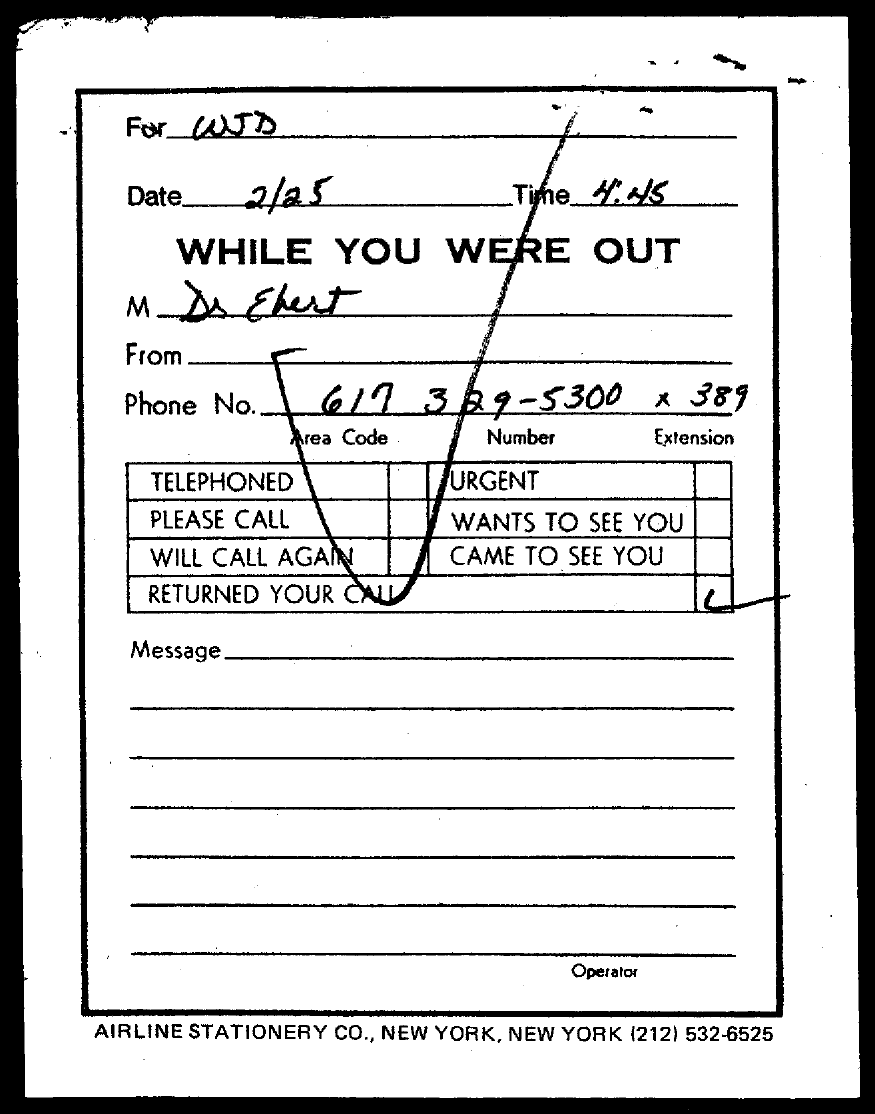To Whom is this letter addressed to?
Offer a terse response. WJD. What is the Date?
Provide a succinct answer. 2/25. What is the Time?
Your response must be concise. 4.45. What is the Phone No.?
Provide a short and direct response. 617 329-5300 x 389. 